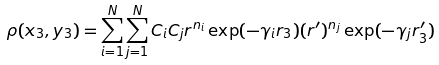Convert formula to latex. <formula><loc_0><loc_0><loc_500><loc_500>\rho ( { x } _ { 3 } , { y } _ { 3 } ) = \sum ^ { N } _ { i = 1 } \sum ^ { N } _ { j = 1 } C _ { i } C _ { j } r ^ { n _ { i } } \exp ( - \gamma _ { i } r _ { 3 } ) ( r ^ { \prime } ) ^ { n _ { j } } \exp ( - \gamma _ { j } r ^ { \prime } _ { 3 } )</formula> 